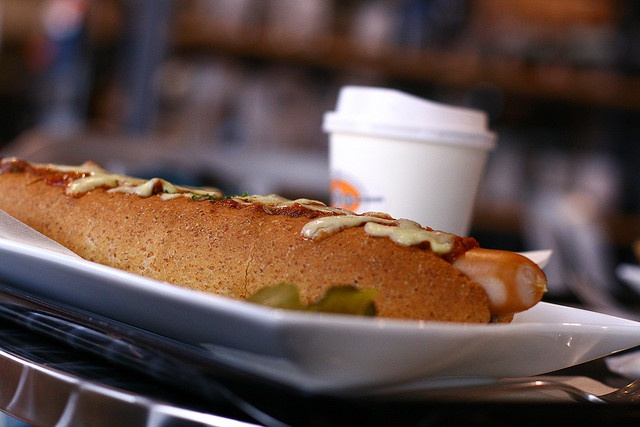Describe the objects in this image and their specific colors. I can see hot dog in brown, salmon, tan, and maroon tones, cup in brown, lavender, darkgray, and gray tones, and fork in brown, black, maroon, and gray tones in this image. 